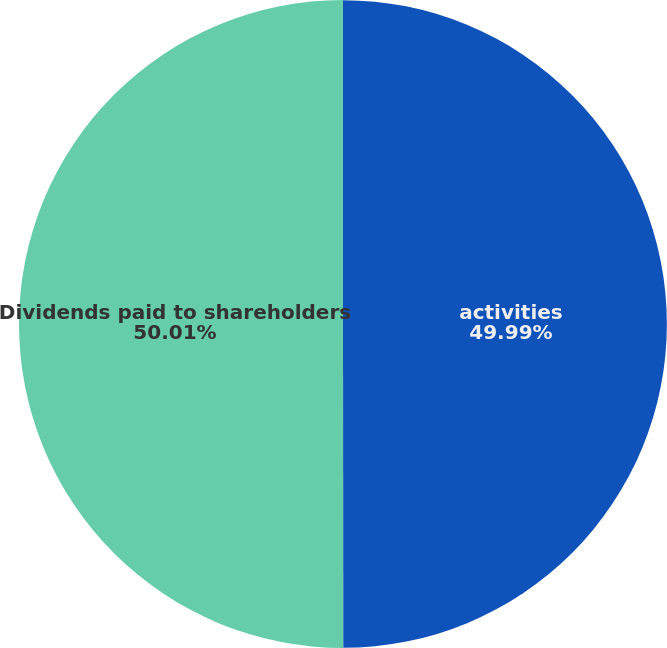Convert chart to OTSL. <chart><loc_0><loc_0><loc_500><loc_500><pie_chart><fcel>activities<fcel>Dividends paid to shareholders<nl><fcel>49.99%<fcel>50.01%<nl></chart> 